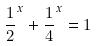Convert formula to latex. <formula><loc_0><loc_0><loc_500><loc_500>\frac { 1 } { 2 } ^ { x } + \frac { 1 } { 4 } ^ { x } = 1</formula> 